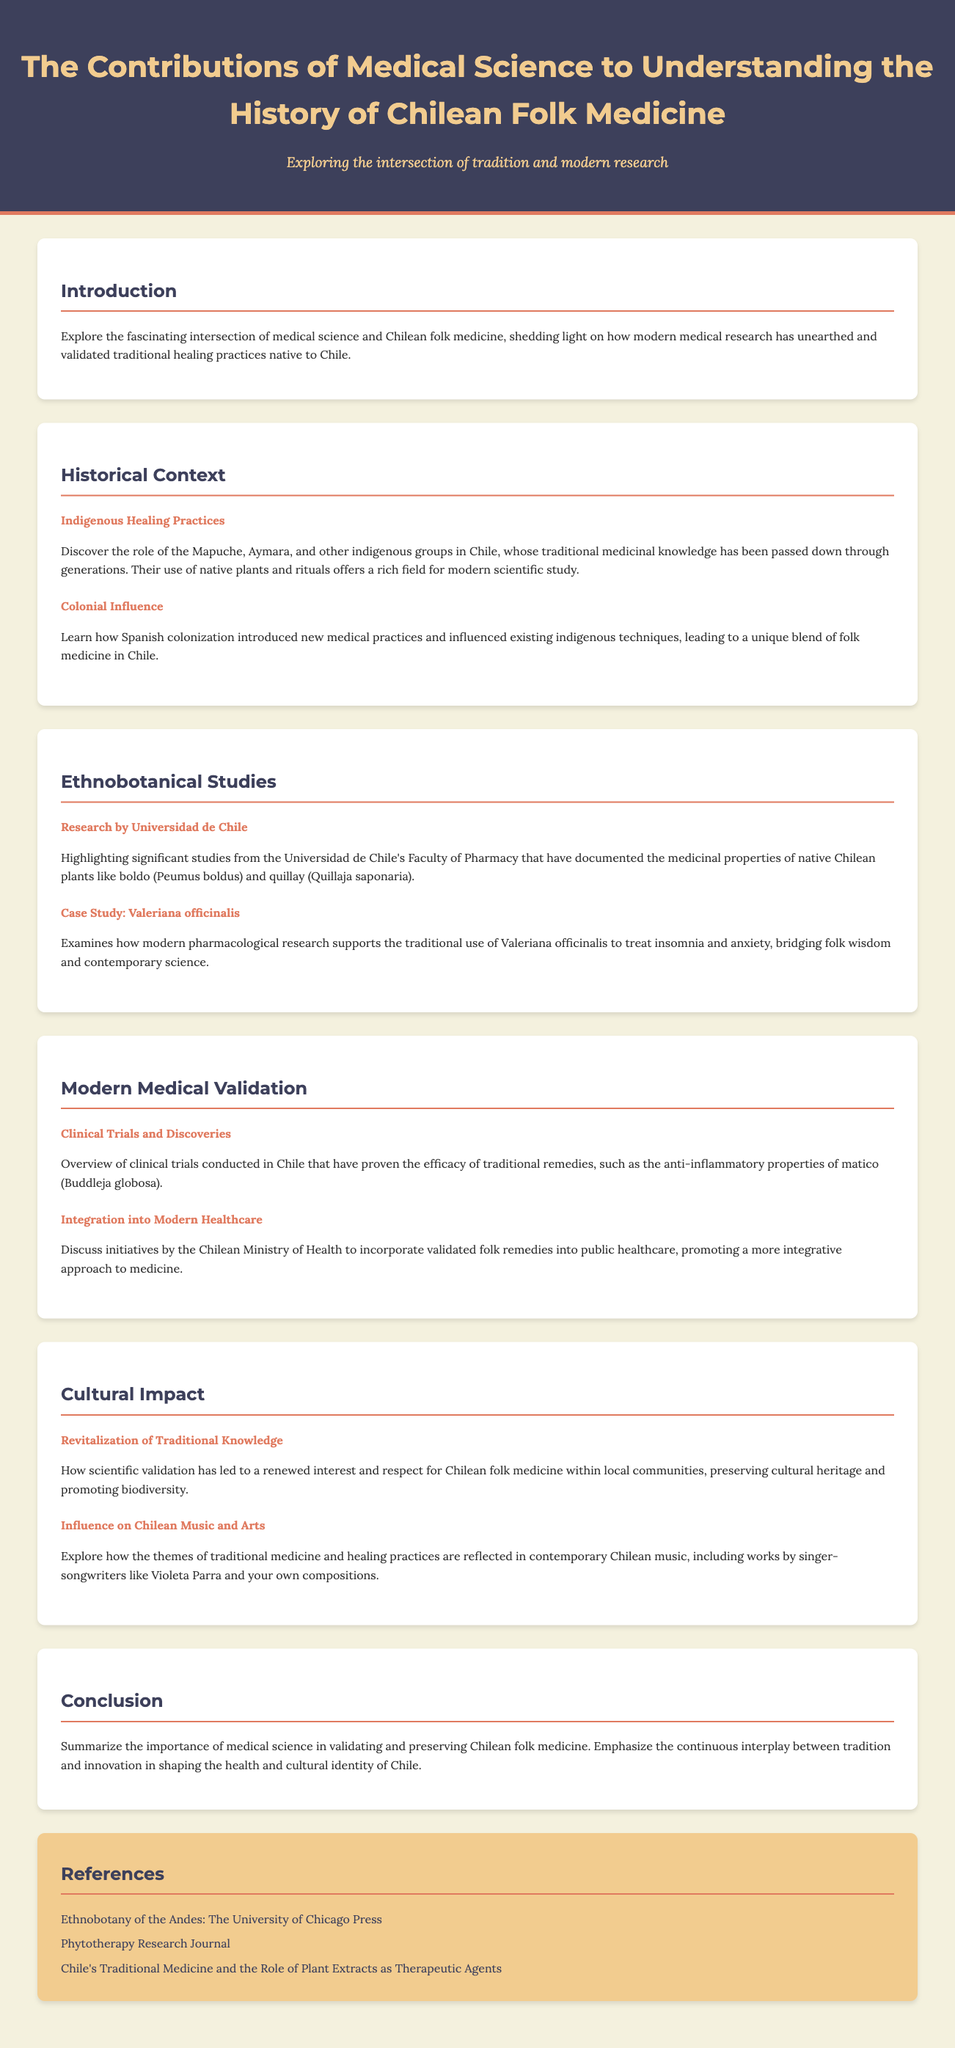What is the title of the document? The title is explicitly stated at the top of the document, which is "The Contributions of Medical Science to Understanding the History of Chilean Folk Medicine."
Answer: The Contributions of Medical Science to Understanding the History of Chilean Folk Medicine Who are the indigenous groups mentioned in the document? The document lists the indigenous groups that are significant in the context of Chilean folk medicine, which are the Mapuche and Aymara.
Answer: Mapuche, Aymara What is the name of the plant studied for its medicinal properties by Universidad de Chile? The document mentions specific plants that have been studied, such as boldo and quillay, by Universidad de Chile's Faculty of Pharmacy.
Answer: Boldo, Quillay What traditional use is supported by modern pharmacological research? The document provides a case study that shows the modern validation of a traditional use, specifically for Valeriana officinalis to treat insomnia and anxiety.
Answer: Valeriana officinalis What initiative does the Chilean Ministry of Health take regarding folk remedies? The document explains that the Ministry of Health has initiatives aimed at incorporating validated folk remedies into public healthcare.
Answer: Incorporate validated folk remedies How has scientific validation affected traditional knowledge? The document states that scientific validation has led to renewed interest and respect for Chilean folk medicine within local communities.
Answer: Renewed interest and respect Which contemporary artists reflect themes of traditional medicine in their work? The document mentions the influence of traditional medicine themes on works by singer-songwriters, specifically referencing Violeta Parra.
Answer: Violeta Parra What type of studies does the section on “Ethnobotanical Studies” highlight? The document emphasizes significant studies related to the medicinal properties of native Chilean plants conducted at Universidad de Chile.
Answer: Medicinal properties of native Chilean plants 